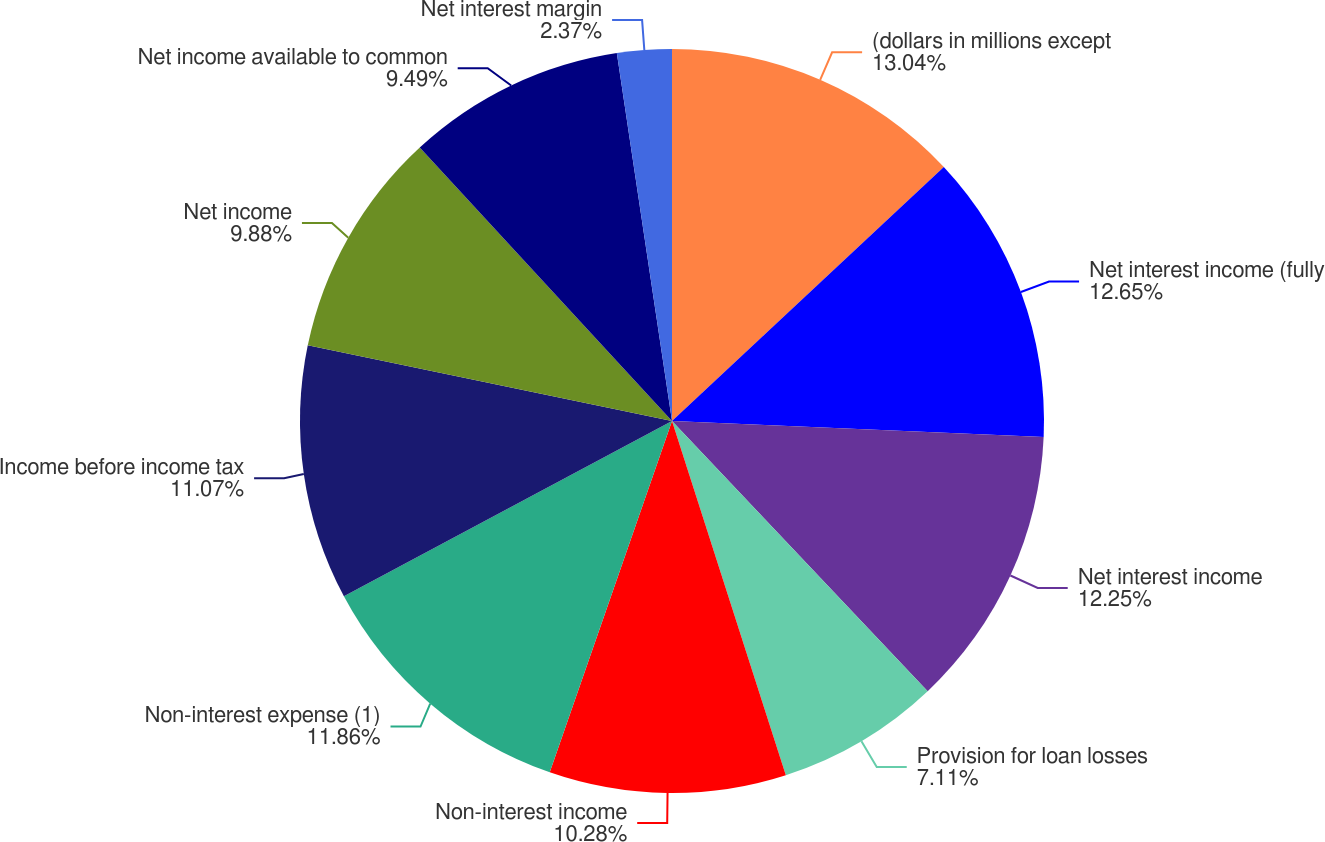<chart> <loc_0><loc_0><loc_500><loc_500><pie_chart><fcel>(dollars in millions except<fcel>Net interest income (fully<fcel>Net interest income<fcel>Provision for loan losses<fcel>Non-interest income<fcel>Non-interest expense (1)<fcel>Income before income tax<fcel>Net income<fcel>Net income available to common<fcel>Net interest margin<nl><fcel>13.04%<fcel>12.65%<fcel>12.25%<fcel>7.11%<fcel>10.28%<fcel>11.86%<fcel>11.07%<fcel>9.88%<fcel>9.49%<fcel>2.37%<nl></chart> 